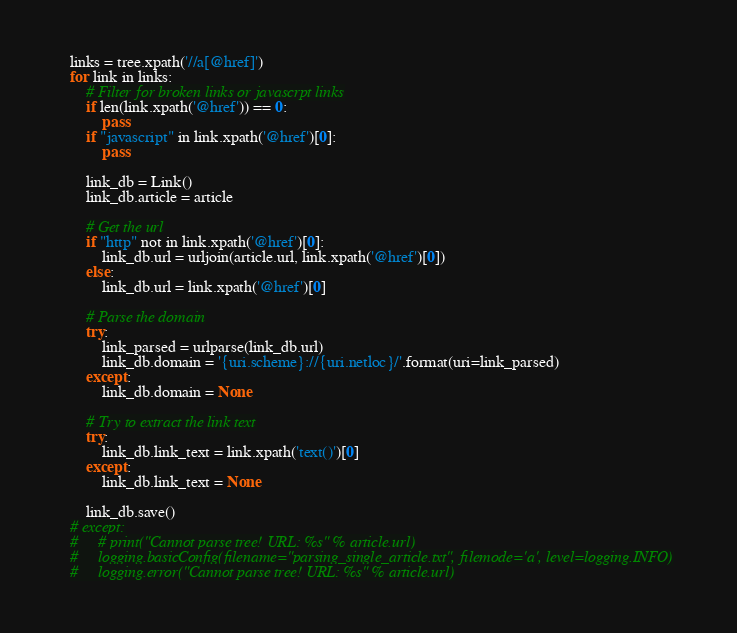Convert code to text. <code><loc_0><loc_0><loc_500><loc_500><_Python_>    links = tree.xpath('//a[@href]')
    for link in links:
        # Filter for broken links or javascrpt links
        if len(link.xpath('@href')) == 0:
            pass
        if "javascript" in link.xpath('@href')[0]:
            pass

        link_db = Link()
        link_db.article = article

        # Get the url
        if "http" not in link.xpath('@href')[0]:
            link_db.url = urljoin(article.url, link.xpath('@href')[0])
        else:
            link_db.url = link.xpath('@href')[0]

        # Parse the domain
        try:
            link_parsed = urlparse(link_db.url)
            link_db.domain = '{uri.scheme}://{uri.netloc}/'.format(uri=link_parsed)
        except:
            link_db.domain = None

        # Try to extract the link text
        try:
            link_db.link_text = link.xpath('text()')[0]
        except:
            link_db.link_text = None

        link_db.save()
    # except:
    #     # print("Cannot parse tree! URL: %s" % article.url)
    #     logging.basicConfig(filename="parsing_single_article.txt", filemode='a', level=logging.INFO)
    #     logging.error("Cannot parse tree! URL: %s" % article.url)
</code> 